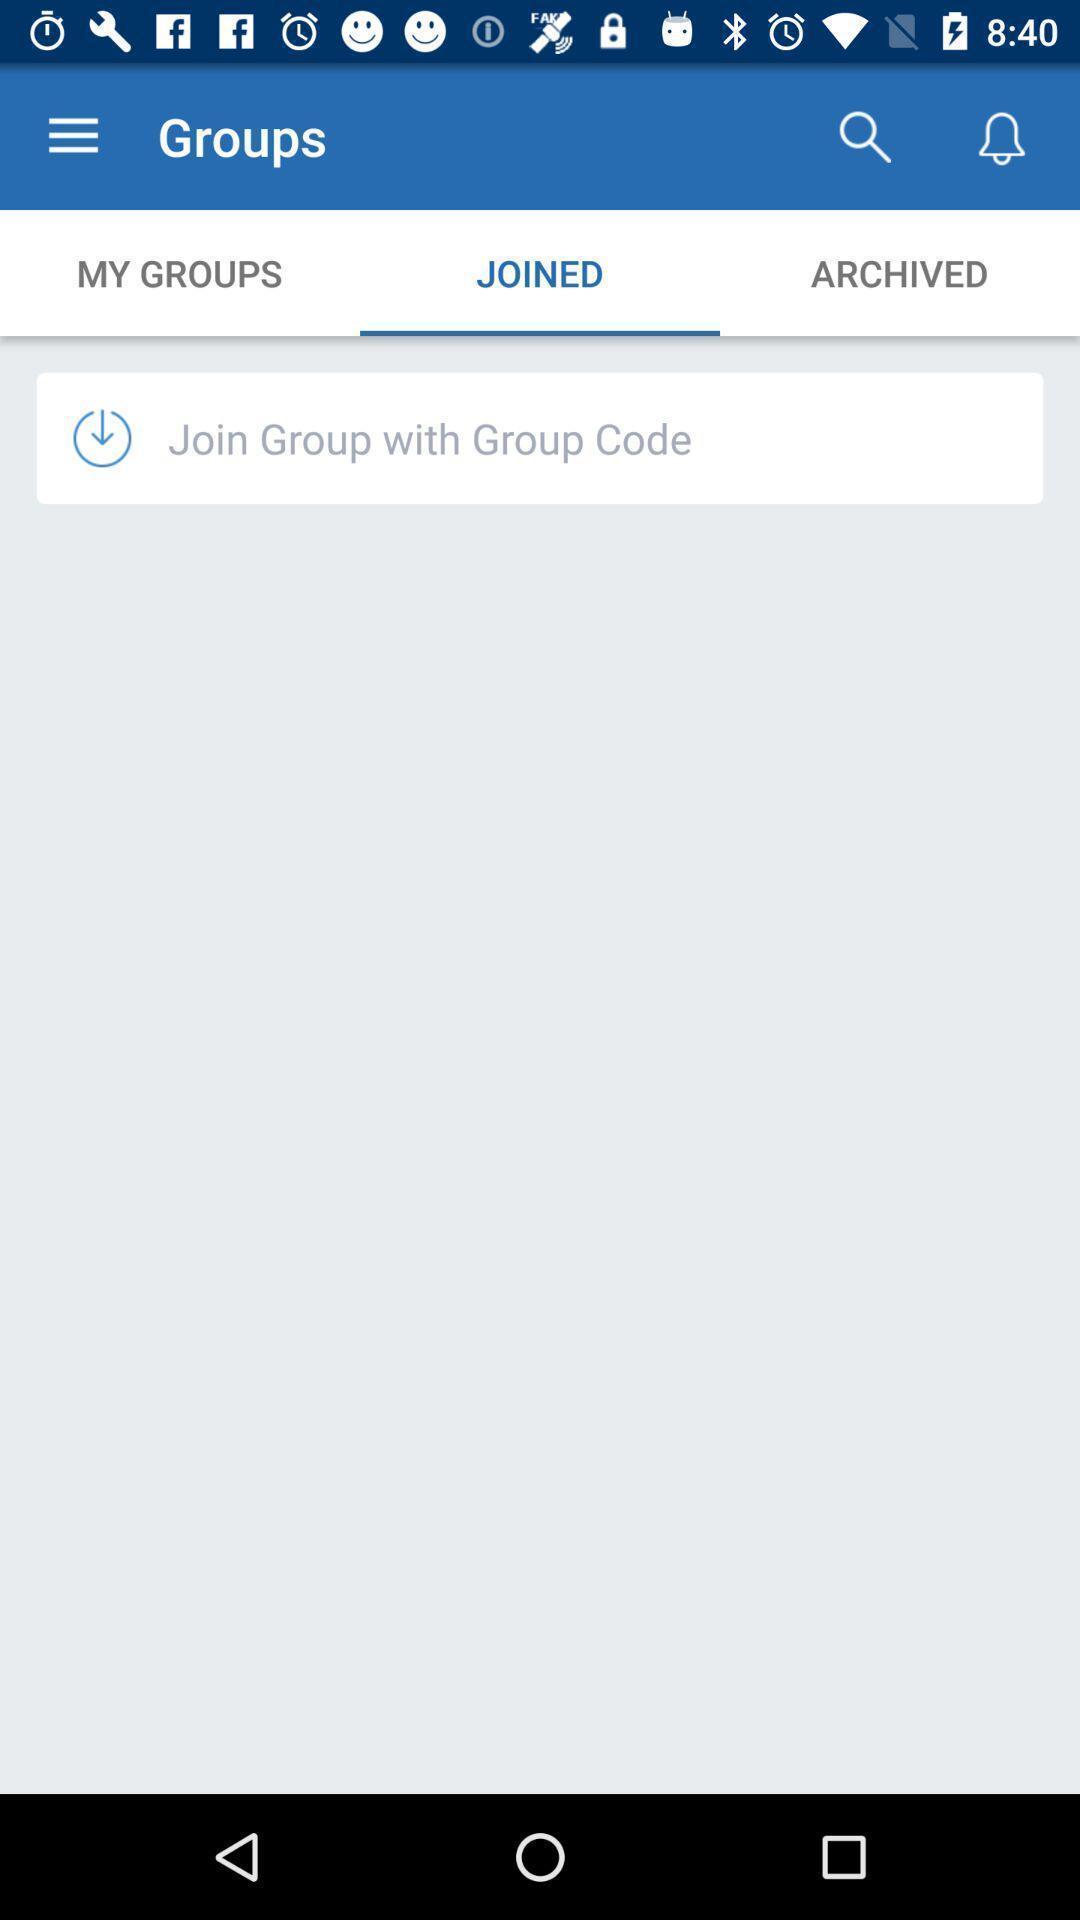Explain the elements present in this screenshot. Screen shows joined option in a community application. 